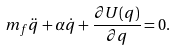<formula> <loc_0><loc_0><loc_500><loc_500>m _ { f } \ddot { q } + \alpha \dot { q } + \frac { \partial U ( q ) } { \partial q } = 0 .</formula> 